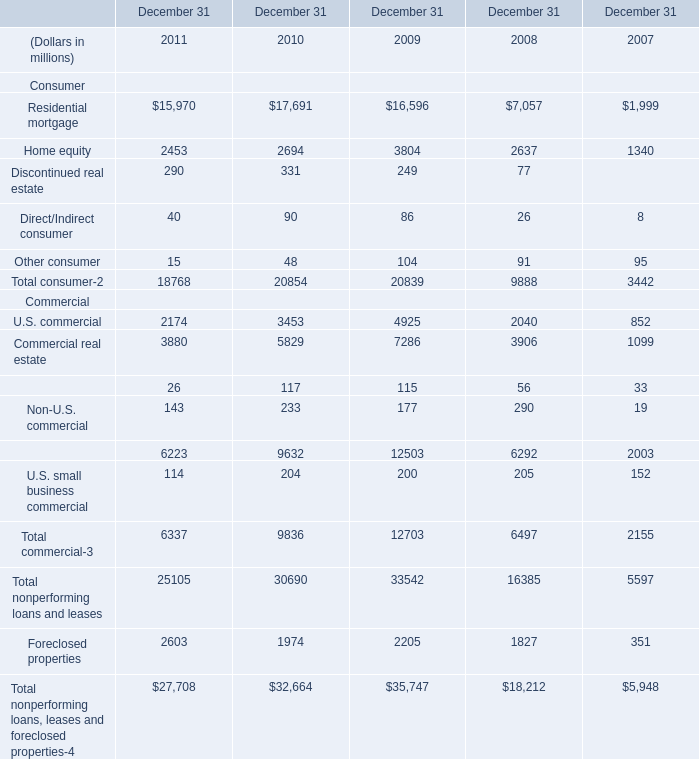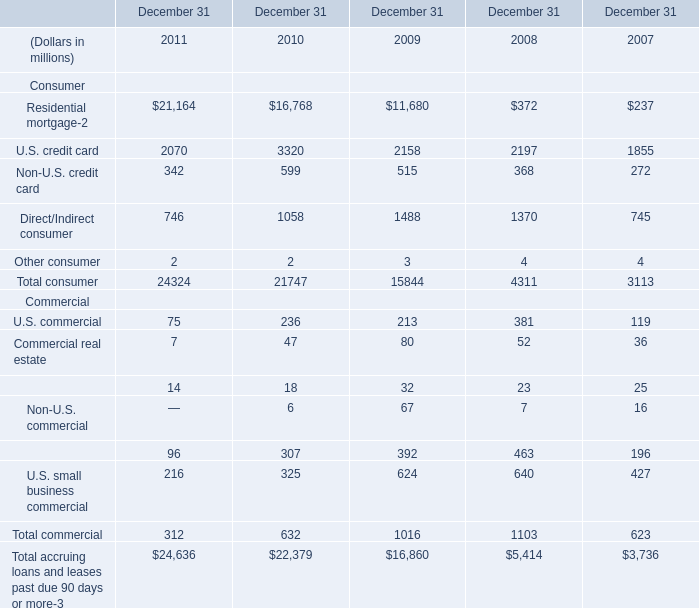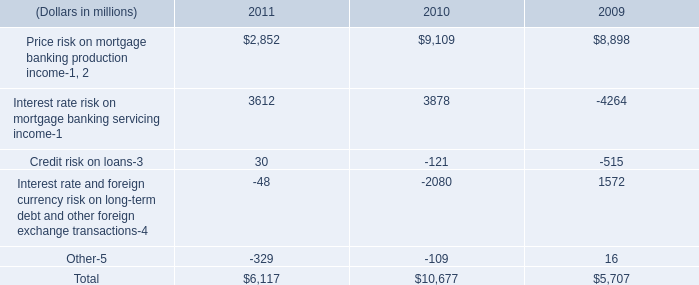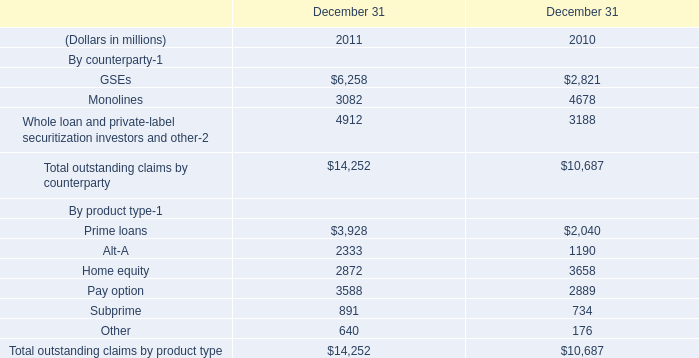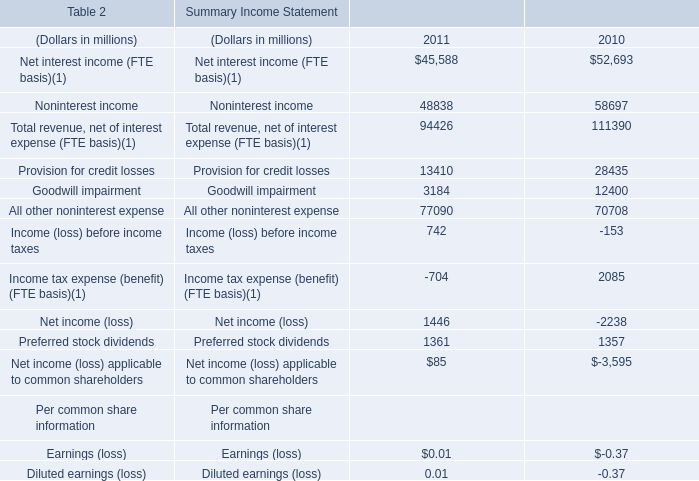What is the average amount of Provision for credit losses of Summary Income Statement 2011, and Price risk on mortgage banking production income of 2009 ? 
Computations: ((13410.0 + 8898.0) / 2)
Answer: 11154.0. 